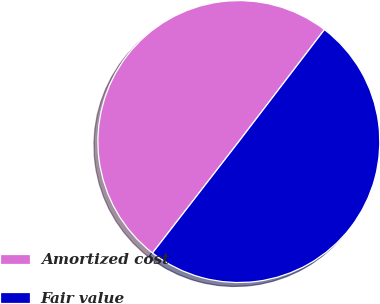<chart> <loc_0><loc_0><loc_500><loc_500><pie_chart><fcel>Amortized cost<fcel>Fair value<nl><fcel>49.9%<fcel>50.1%<nl></chart> 